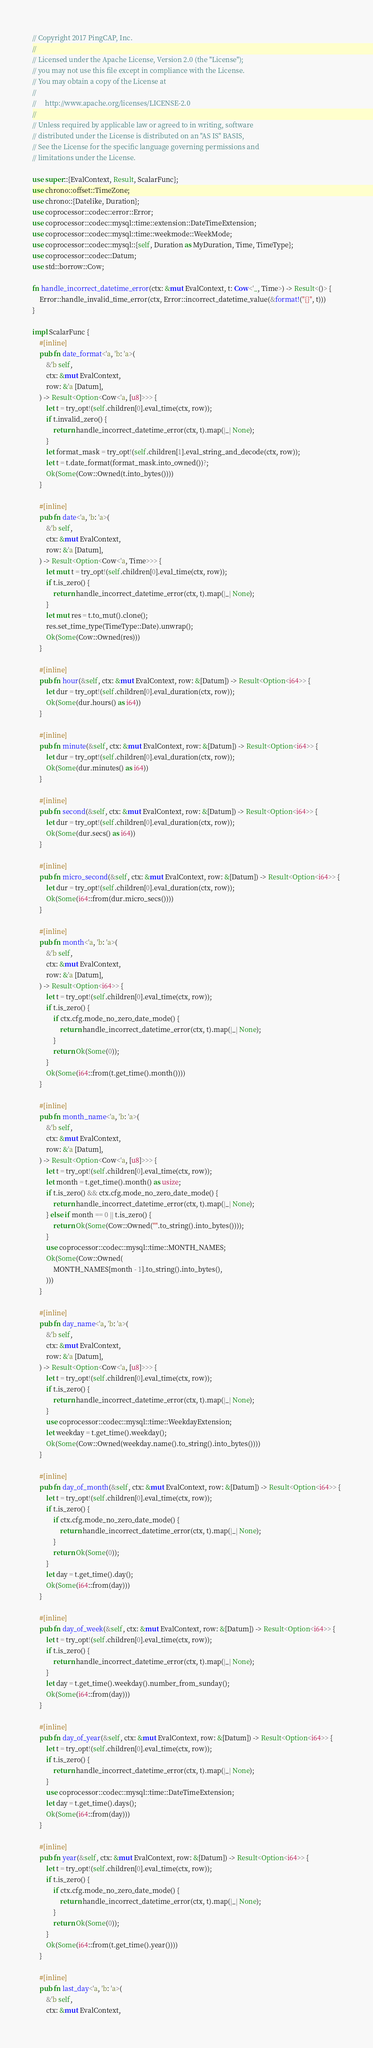Convert code to text. <code><loc_0><loc_0><loc_500><loc_500><_Rust_>// Copyright 2017 PingCAP, Inc.
//
// Licensed under the Apache License, Version 2.0 (the "License");
// you may not use this file except in compliance with the License.
// You may obtain a copy of the License at
//
//     http://www.apache.org/licenses/LICENSE-2.0
//
// Unless required by applicable law or agreed to in writing, software
// distributed under the License is distributed on an "AS IS" BASIS,
// See the License for the specific language governing permissions and
// limitations under the License.

use super::{EvalContext, Result, ScalarFunc};
use chrono::offset::TimeZone;
use chrono::{Datelike, Duration};
use coprocessor::codec::error::Error;
use coprocessor::codec::mysql::time::extension::DateTimeExtension;
use coprocessor::codec::mysql::time::weekmode::WeekMode;
use coprocessor::codec::mysql::{self, Duration as MyDuration, Time, TimeType};
use coprocessor::codec::Datum;
use std::borrow::Cow;

fn handle_incorrect_datetime_error(ctx: &mut EvalContext, t: Cow<'_, Time>) -> Result<()> {
    Error::handle_invalid_time_error(ctx, Error::incorrect_datetime_value(&format!("{}", t)))
}

impl ScalarFunc {
    #[inline]
    pub fn date_format<'a, 'b: 'a>(
        &'b self,
        ctx: &mut EvalContext,
        row: &'a [Datum],
    ) -> Result<Option<Cow<'a, [u8]>>> {
        let t = try_opt!(self.children[0].eval_time(ctx, row));
        if t.invalid_zero() {
            return handle_incorrect_datetime_error(ctx, t).map(|_| None);
        }
        let format_mask = try_opt!(self.children[1].eval_string_and_decode(ctx, row));
        let t = t.date_format(format_mask.into_owned())?;
        Ok(Some(Cow::Owned(t.into_bytes())))
    }

    #[inline]
    pub fn date<'a, 'b: 'a>(
        &'b self,
        ctx: &mut EvalContext,
        row: &'a [Datum],
    ) -> Result<Option<Cow<'a, Time>>> {
        let mut t = try_opt!(self.children[0].eval_time(ctx, row));
        if t.is_zero() {
            return handle_incorrect_datetime_error(ctx, t).map(|_| None);
        }
        let mut res = t.to_mut().clone();
        res.set_time_type(TimeType::Date).unwrap();
        Ok(Some(Cow::Owned(res)))
    }

    #[inline]
    pub fn hour(&self, ctx: &mut EvalContext, row: &[Datum]) -> Result<Option<i64>> {
        let dur = try_opt!(self.children[0].eval_duration(ctx, row));
        Ok(Some(dur.hours() as i64))
    }

    #[inline]
    pub fn minute(&self, ctx: &mut EvalContext, row: &[Datum]) -> Result<Option<i64>> {
        let dur = try_opt!(self.children[0].eval_duration(ctx, row));
        Ok(Some(dur.minutes() as i64))
    }

    #[inline]
    pub fn second(&self, ctx: &mut EvalContext, row: &[Datum]) -> Result<Option<i64>> {
        let dur = try_opt!(self.children[0].eval_duration(ctx, row));
        Ok(Some(dur.secs() as i64))
    }

    #[inline]
    pub fn micro_second(&self, ctx: &mut EvalContext, row: &[Datum]) -> Result<Option<i64>> {
        let dur = try_opt!(self.children[0].eval_duration(ctx, row));
        Ok(Some(i64::from(dur.micro_secs())))
    }

    #[inline]
    pub fn month<'a, 'b: 'a>(
        &'b self,
        ctx: &mut EvalContext,
        row: &'a [Datum],
    ) -> Result<Option<i64>> {
        let t = try_opt!(self.children[0].eval_time(ctx, row));
        if t.is_zero() {
            if ctx.cfg.mode_no_zero_date_mode() {
                return handle_incorrect_datetime_error(ctx, t).map(|_| None);
            }
            return Ok(Some(0));
        }
        Ok(Some(i64::from(t.get_time().month())))
    }

    #[inline]
    pub fn month_name<'a, 'b: 'a>(
        &'b self,
        ctx: &mut EvalContext,
        row: &'a [Datum],
    ) -> Result<Option<Cow<'a, [u8]>>> {
        let t = try_opt!(self.children[0].eval_time(ctx, row));
        let month = t.get_time().month() as usize;
        if t.is_zero() && ctx.cfg.mode_no_zero_date_mode() {
            return handle_incorrect_datetime_error(ctx, t).map(|_| None);
        } else if month == 0 || t.is_zero() {
            return Ok(Some(Cow::Owned("".to_string().into_bytes())));
        }
        use coprocessor::codec::mysql::time::MONTH_NAMES;
        Ok(Some(Cow::Owned(
            MONTH_NAMES[month - 1].to_string().into_bytes(),
        )))
    }

    #[inline]
    pub fn day_name<'a, 'b: 'a>(
        &'b self,
        ctx: &mut EvalContext,
        row: &'a [Datum],
    ) -> Result<Option<Cow<'a, [u8]>>> {
        let t = try_opt!(self.children[0].eval_time(ctx, row));
        if t.is_zero() {
            return handle_incorrect_datetime_error(ctx, t).map(|_| None);
        }
        use coprocessor::codec::mysql::time::WeekdayExtension;
        let weekday = t.get_time().weekday();
        Ok(Some(Cow::Owned(weekday.name().to_string().into_bytes())))
    }

    #[inline]
    pub fn day_of_month(&self, ctx: &mut EvalContext, row: &[Datum]) -> Result<Option<i64>> {
        let t = try_opt!(self.children[0].eval_time(ctx, row));
        if t.is_zero() {
            if ctx.cfg.mode_no_zero_date_mode() {
                return handle_incorrect_datetime_error(ctx, t).map(|_| None);
            }
            return Ok(Some(0));
        }
        let day = t.get_time().day();
        Ok(Some(i64::from(day)))
    }

    #[inline]
    pub fn day_of_week(&self, ctx: &mut EvalContext, row: &[Datum]) -> Result<Option<i64>> {
        let t = try_opt!(self.children[0].eval_time(ctx, row));
        if t.is_zero() {
            return handle_incorrect_datetime_error(ctx, t).map(|_| None);
        }
        let day = t.get_time().weekday().number_from_sunday();
        Ok(Some(i64::from(day)))
    }

    #[inline]
    pub fn day_of_year(&self, ctx: &mut EvalContext, row: &[Datum]) -> Result<Option<i64>> {
        let t = try_opt!(self.children[0].eval_time(ctx, row));
        if t.is_zero() {
            return handle_incorrect_datetime_error(ctx, t).map(|_| None);
        }
        use coprocessor::codec::mysql::time::DateTimeExtension;
        let day = t.get_time().days();
        Ok(Some(i64::from(day)))
    }

    #[inline]
    pub fn year(&self, ctx: &mut EvalContext, row: &[Datum]) -> Result<Option<i64>> {
        let t = try_opt!(self.children[0].eval_time(ctx, row));
        if t.is_zero() {
            if ctx.cfg.mode_no_zero_date_mode() {
                return handle_incorrect_datetime_error(ctx, t).map(|_| None);
            }
            return Ok(Some(0));
        }
        Ok(Some(i64::from(t.get_time().year())))
    }

    #[inline]
    pub fn last_day<'a, 'b: 'a>(
        &'b self,
        ctx: &mut EvalContext,</code> 